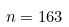Convert formula to latex. <formula><loc_0><loc_0><loc_500><loc_500>n = 1 6 3</formula> 